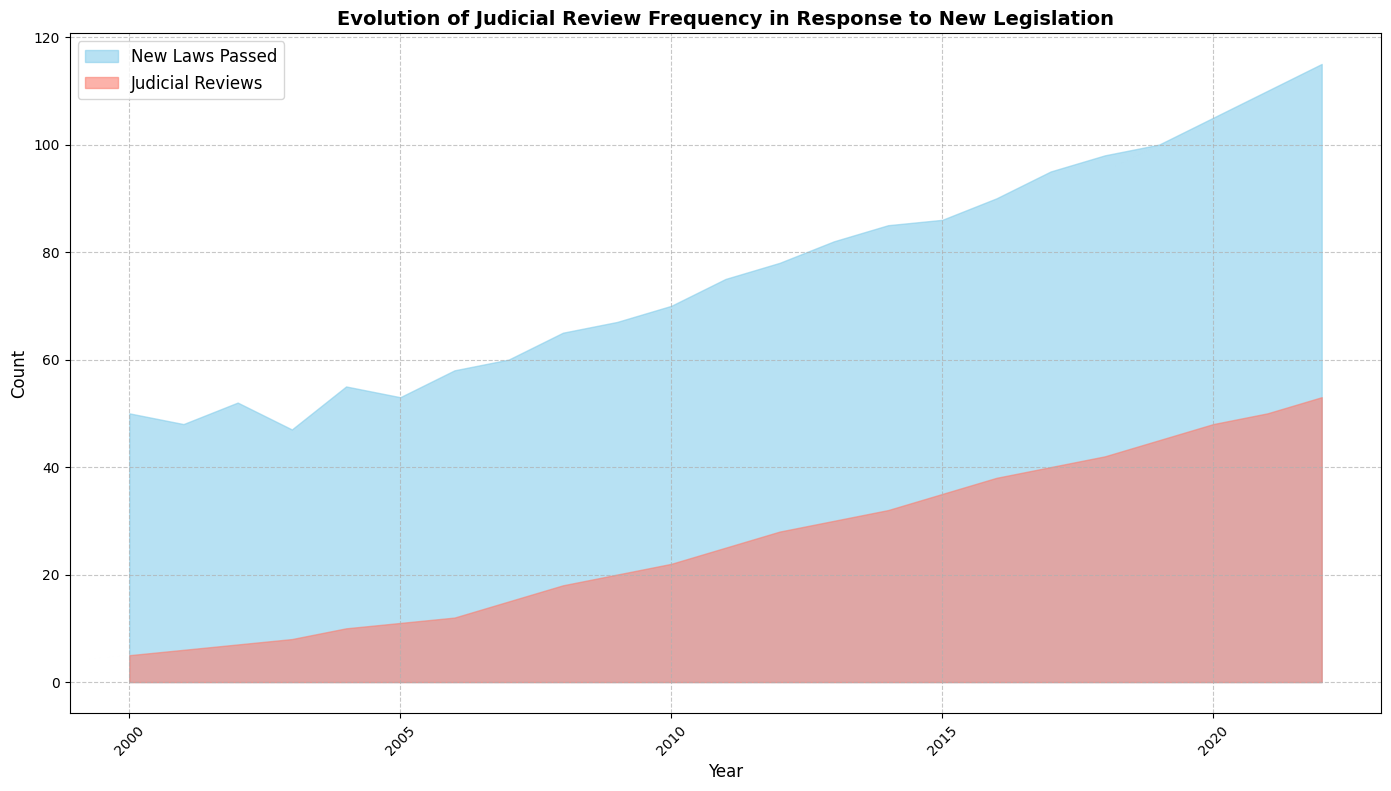When did the number of judicial reviews first reach 20? The area chart shows a rising trend in judicial reviews. Observing the chart, the first year where the count of judicial reviews hits 20 is visible at around the year 2009.
Answer: 2009 In which year was the difference between new laws passed and judicial reviews the largest? By observing the chart visually, the largest gap between the areas representing new laws passed and judicial reviews occurs in the early 2000s. Specifically, the year with the largest visible difference is around 2000.
Answer: 2000 In which year did the number of judicial reviews exceed 30 for the first time? Looking at the chart and identifying the point where the judicial reviews first exceed 30, we find that this happens in the year 2013.
Answer: 2013 By how much did the number of new laws passed increase from 2000 to 2022? To find the increase, subtract the number of new laws passed in 2000 from that in 2022. From the data, 2022 has 115 new laws passed and 2000 has 50 new laws passed. The increase is 115 - 50 = 65.
Answer: 65 What is the ratio of judicial reviews to new laws passed in 2022? In 2022, the number of judicial reviews is 53, and new laws passed is 115. The ratio is 53 / 115, which simplifies to approximately 0.46.
Answer: 0.46 Which year had an equal increase in both judicial reviews and new laws passed compared to the previous year? By checking the differences year by year, we see that in 2010 there were increases of 2 for both judicial reviews and new laws passed compared to 2009.
Answer: 2010 What trend do you observe in the number of judicial reviews relative to the number of new laws passed over the years? Observing the chart, initially, the number of new laws passed is substantially higher than the number of judicial reviews. Over time, both values increase, with judicial reviews increasing at a faster rate, approaching the count of new laws passed.
Answer: Increasing alignment over time What visual difference can you see between the areas representing new laws passed and judicial reviews? The area representing new laws passed is shaded in sky blue, while the area for judicial reviews is shaded in salmon. The area for new laws passed starts off significantly larger, but the gap narrows over time.
Answer: Different colors and narrowing gap By how much did the number of judicial reviews increase from 2007 to 2008? From the data, the number of judicial reviews in 2007 is 15, and in 2008 it is 18. The increase is 18 - 15 = 3.
Answer: 3 When was the rate of increase in judicial reviews noticeably more rapid than in new laws passed? Observing the steeper visual slope in the area of judicial reviews compared to new laws passed, this more rapid increase is noticeable from around 2010 onward.
Answer: Around 2010 onward 